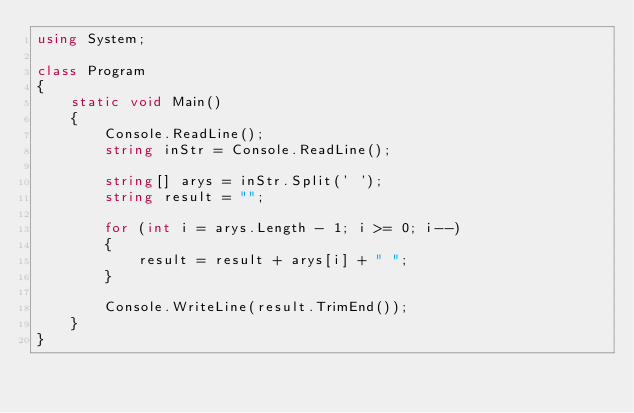Convert code to text. <code><loc_0><loc_0><loc_500><loc_500><_C#_>using System;

class Program
{
    static void Main()
    {
        Console.ReadLine();
        string inStr = Console.ReadLine();

        string[] arys = inStr.Split(' ');
        string result = "";

        for (int i = arys.Length - 1; i >= 0; i--)
        {
            result = result + arys[i] + " ";
        }

        Console.WriteLine(result.TrimEnd());
    }
}
</code> 